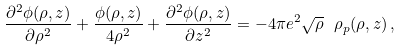<formula> <loc_0><loc_0><loc_500><loc_500>\frac { \partial ^ { 2 } \phi ( \rho , z ) } { \partial \rho ^ { 2 } } + \frac { \phi ( \rho , z ) } { 4 \rho ^ { 2 } } + \frac { \partial ^ { 2 } \phi ( \rho , z ) } { \partial z ^ { 2 } } = - 4 \pi e ^ { 2 } \sqrt { \rho } \ \rho _ { p } ( \rho , z ) \, ,</formula> 